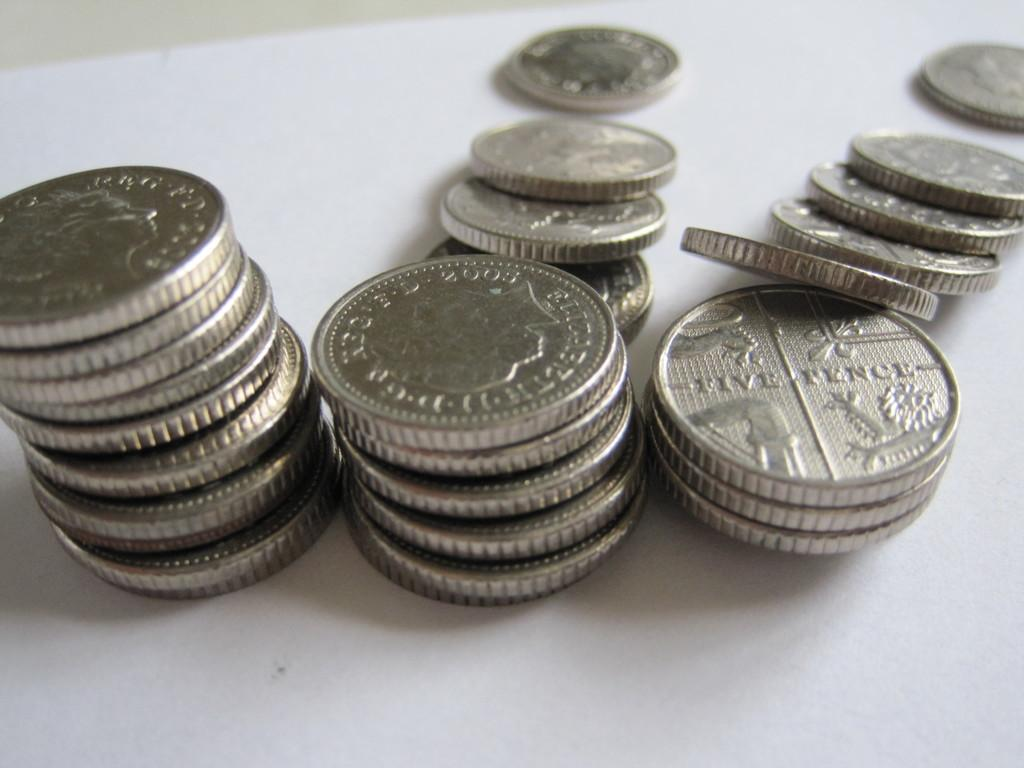Provide a one-sentence caption for the provided image. many coins and one that says five fence on it. 